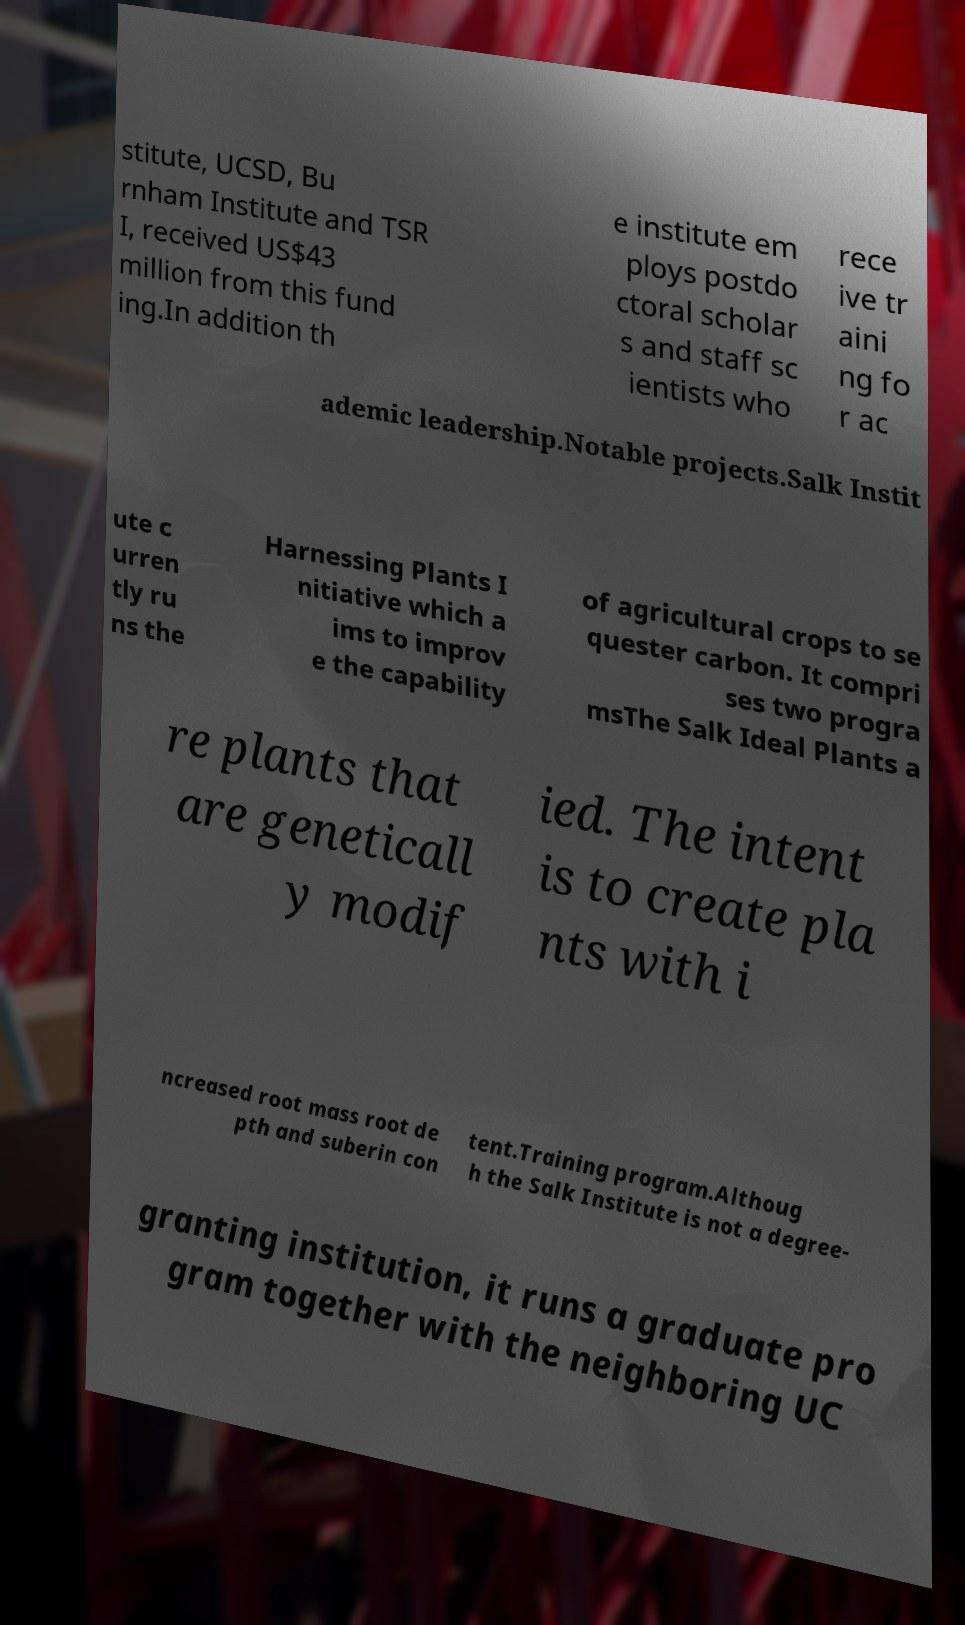There's text embedded in this image that I need extracted. Can you transcribe it verbatim? stitute, UCSD, Bu rnham Institute and TSR I, received US$43 million from this fund ing.In addition th e institute em ploys postdo ctoral scholar s and staff sc ientists who rece ive tr aini ng fo r ac ademic leadership.Notable projects.Salk Instit ute c urren tly ru ns the Harnessing Plants I nitiative which a ims to improv e the capability of agricultural crops to se quester carbon. It compri ses two progra msThe Salk Ideal Plants a re plants that are geneticall y modif ied. The intent is to create pla nts with i ncreased root mass root de pth and suberin con tent.Training program.Althoug h the Salk Institute is not a degree- granting institution, it runs a graduate pro gram together with the neighboring UC 